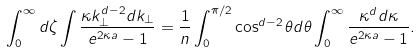<formula> <loc_0><loc_0><loc_500><loc_500>\int _ { 0 } ^ { \infty } d \zeta \int \frac { \kappa k _ { \perp } ^ { d - 2 } d k _ { \perp } } { e ^ { 2 \kappa a } - 1 } = \frac { 1 } { n } \int _ { 0 } ^ { \pi / 2 } \cos ^ { d - 2 } \theta d \theta \int _ { 0 } ^ { \infty } \frac { \kappa ^ { d } d \kappa } { e ^ { 2 \kappa a } - 1 } .</formula> 